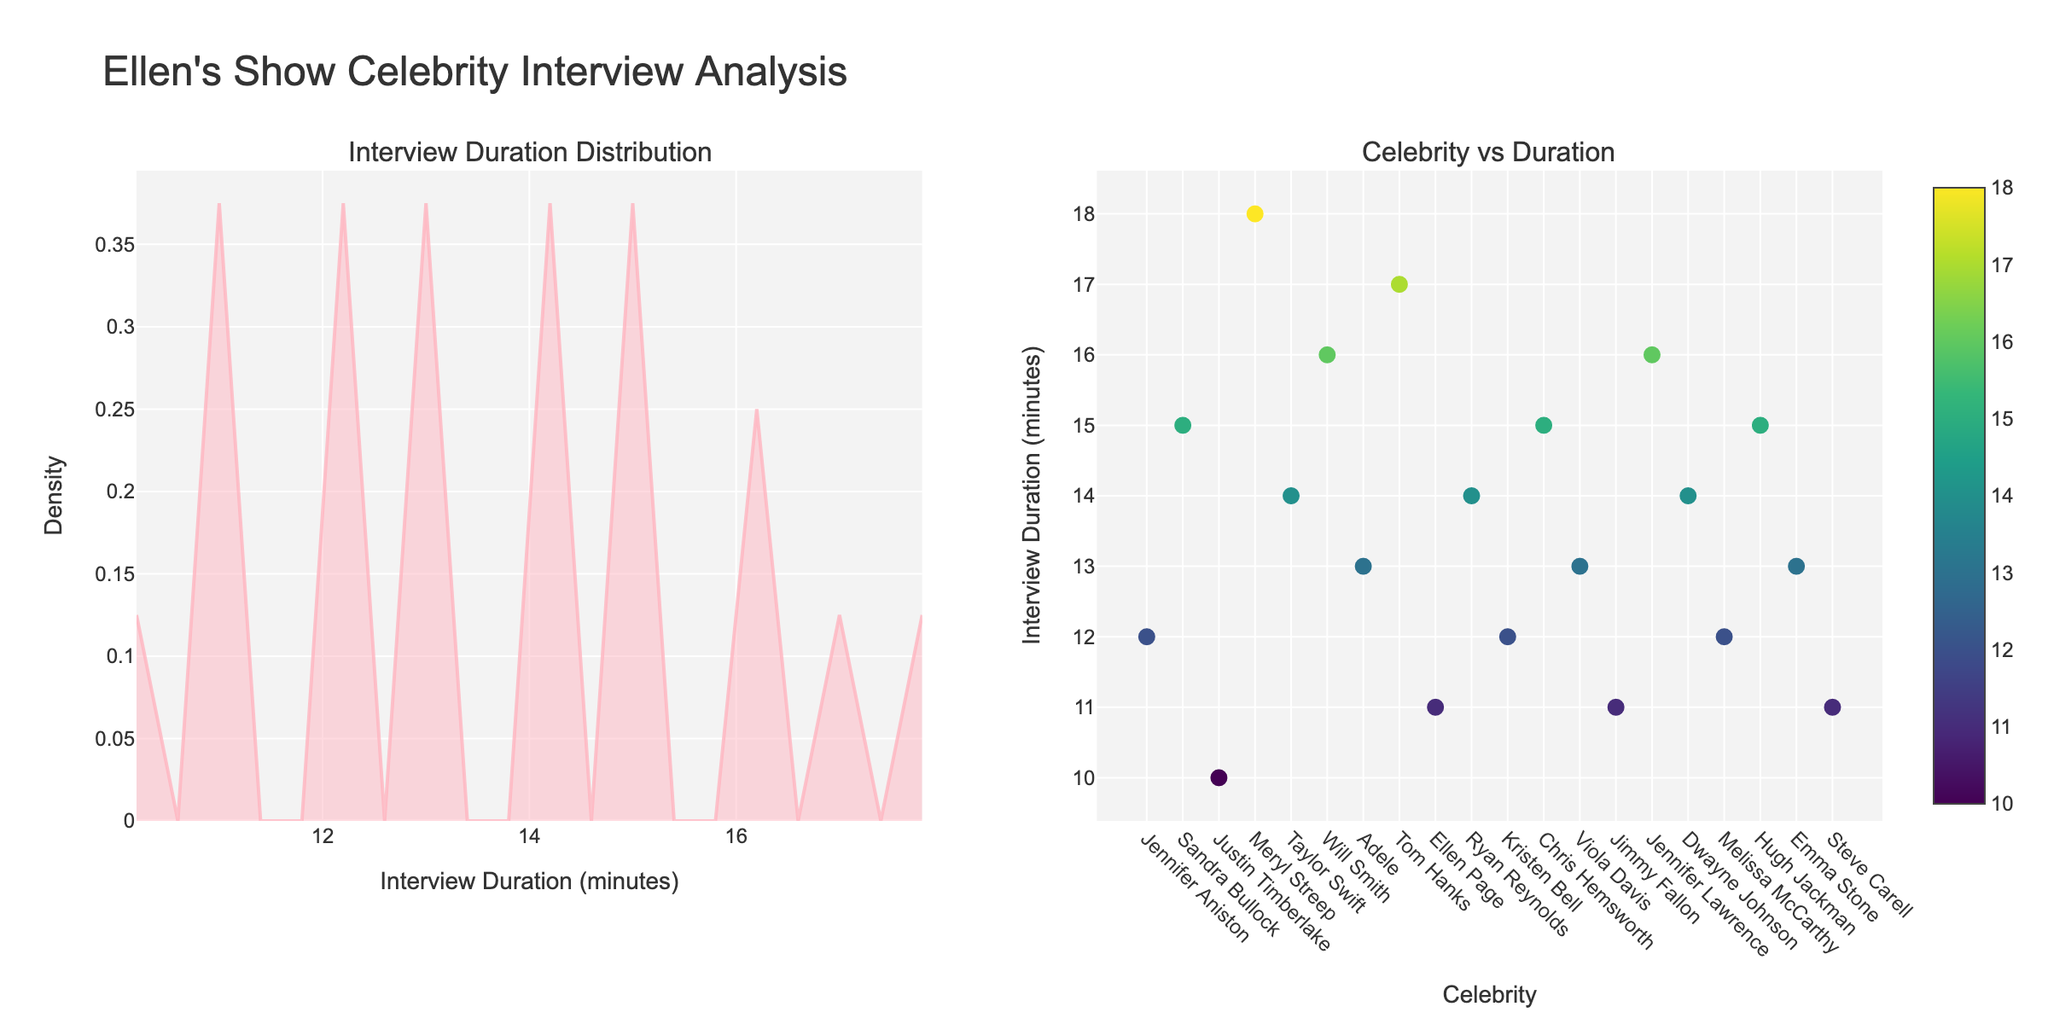What's the title of the entire figure? The title of the entire figure is displayed at the top and provides a brief description of the contents of the figure. The title reads "Ellen's Show Celebrity Interview Analysis".
Answer: Ellen's Show Celebrity Interview Analysis What does the x-axis on the left subplot represent? The left subplot is a density plot, and the x-axis represents the "Interview Duration (minutes)" as indicated by the axis title.
Answer: Interview Duration (minutes) Which celebrity had the shortest interview duration? By observing the scatter plot on the right subplot, the data point with the lowest value on the y-axis (Interview Duration) corresponds to Justin Timberlake with a duration of 10 minutes.
Answer: Justin Timberlake What's the maximum interview duration from the scatter plot? The highest point on the y-axis of the scatter plot corresponds to the maximum interview duration. The highest visible point is 18 minutes for Meryl Streep.
Answer: 18 minutes How is the density represented for interview durations on the left plot? In the density plot, the density is represented by the area under the curve, which is filled with a color. The higher the curve, the denser the region.
Answer: By the area under the curve What's the average interview duration for the celebrities shown? Sum of all interview durations: 12 + 15 + 10 + 18 + 14 + 16 + 13 + 17 + 11 + 14 + 12 + 15 + 13 + 11 + 16 + 14 + 12 + 15 + 13 + 11 =  280; Number of celebrities: 20; Average duration = 280 / 20
Answer: 14 minutes Which two celebrities have an interview duration of 15 minutes? By looking at the scatter plot, the data points that align with the y-axis value of 15 are Sandra Bullock, Chris Hemsworth, and Hugh Jackman.
Answer: Sandra Bullock, Chris Hemsworth What's the general trend observed on the density plot of interview durations? The density plot shows a single peak, indicating that most interview durations are concentrated around the center of the range. The peak suggests that the most common duration is around 13-15 minutes.
Answer: Most common duration is 13-15 minutes Which celebrity's interview duration stands out as the longest compared to others? Observing the scatter plot, the highest data point indicates the longest interview duration, which is Meryl Streep with 18 minutes.
Answer: Meryl Streep 